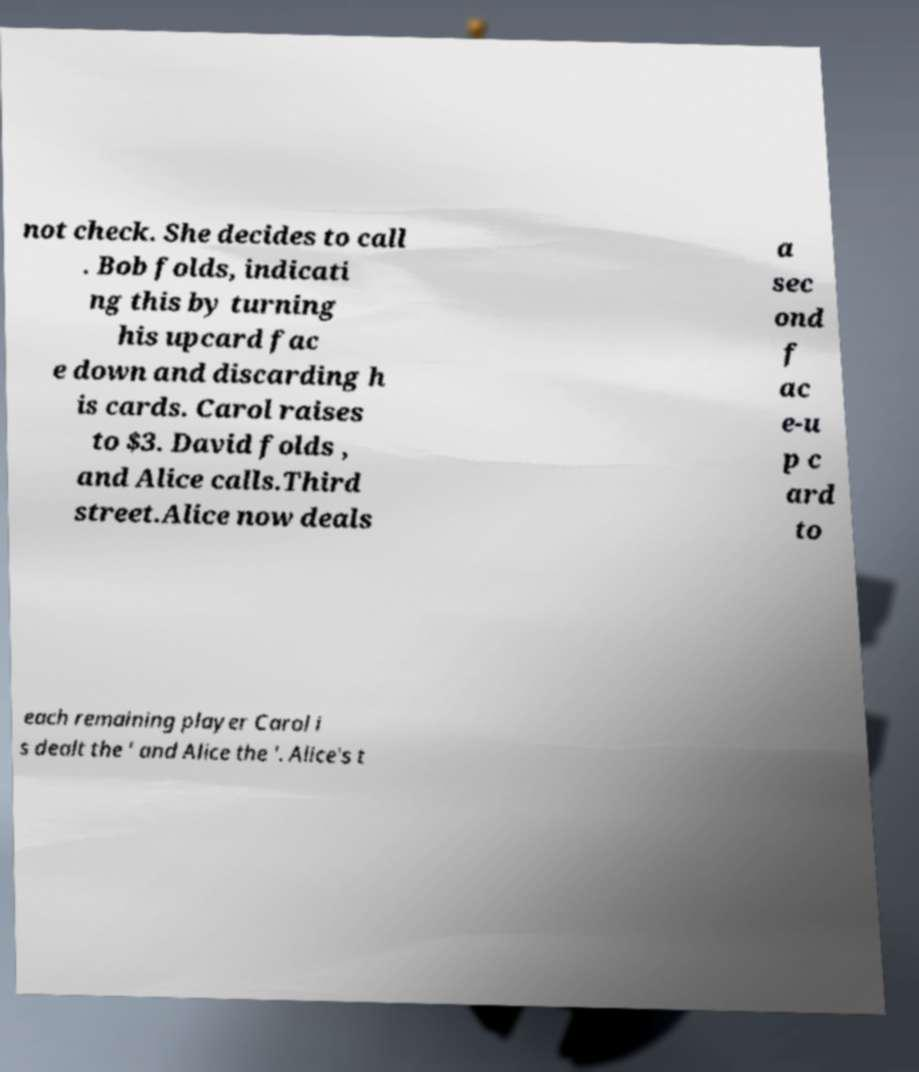There's text embedded in this image that I need extracted. Can you transcribe it verbatim? not check. She decides to call . Bob folds, indicati ng this by turning his upcard fac e down and discarding h is cards. Carol raises to $3. David folds , and Alice calls.Third street.Alice now deals a sec ond f ac e-u p c ard to each remaining player Carol i s dealt the ' and Alice the '. Alice's t 